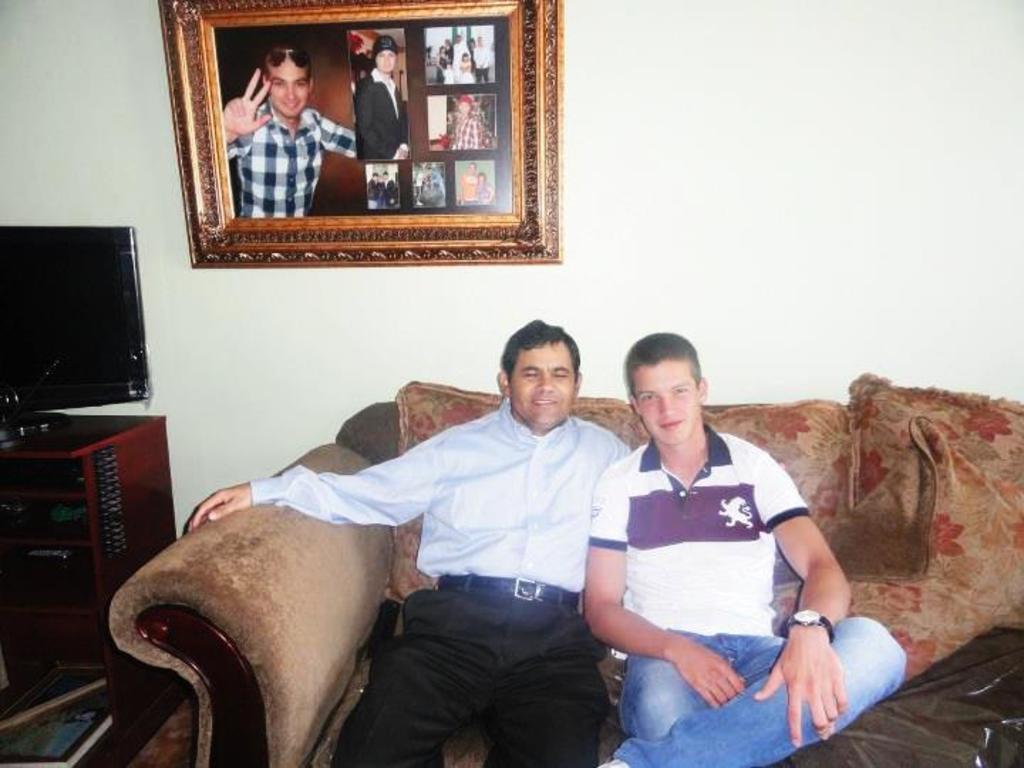How would you summarize this image in a sentence or two? In this picture I can see couple of men sitting on the sofa and I can see a television on the table and a book on another table and a photo frame on the wall. 